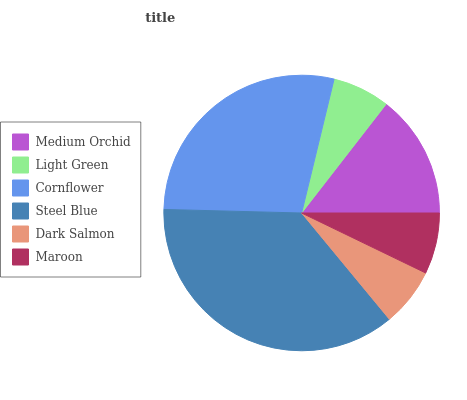Is Light Green the minimum?
Answer yes or no. Yes. Is Steel Blue the maximum?
Answer yes or no. Yes. Is Cornflower the minimum?
Answer yes or no. No. Is Cornflower the maximum?
Answer yes or no. No. Is Cornflower greater than Light Green?
Answer yes or no. Yes. Is Light Green less than Cornflower?
Answer yes or no. Yes. Is Light Green greater than Cornflower?
Answer yes or no. No. Is Cornflower less than Light Green?
Answer yes or no. No. Is Medium Orchid the high median?
Answer yes or no. Yes. Is Maroon the low median?
Answer yes or no. Yes. Is Light Green the high median?
Answer yes or no. No. Is Dark Salmon the low median?
Answer yes or no. No. 